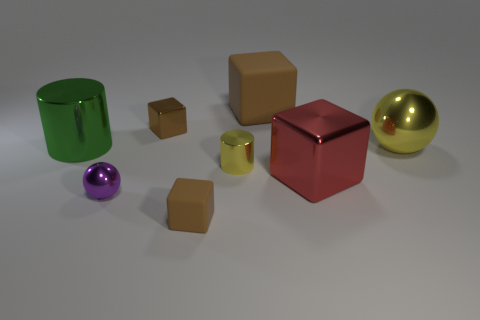Subtract all cyan spheres. How many brown cubes are left? 3 Add 2 green cylinders. How many objects exist? 10 Subtract all cylinders. How many objects are left? 6 Subtract 3 brown cubes. How many objects are left? 5 Subtract all small brown cubes. Subtract all big matte blocks. How many objects are left? 5 Add 5 tiny purple balls. How many tiny purple balls are left? 6 Add 4 big brown rubber blocks. How many big brown rubber blocks exist? 5 